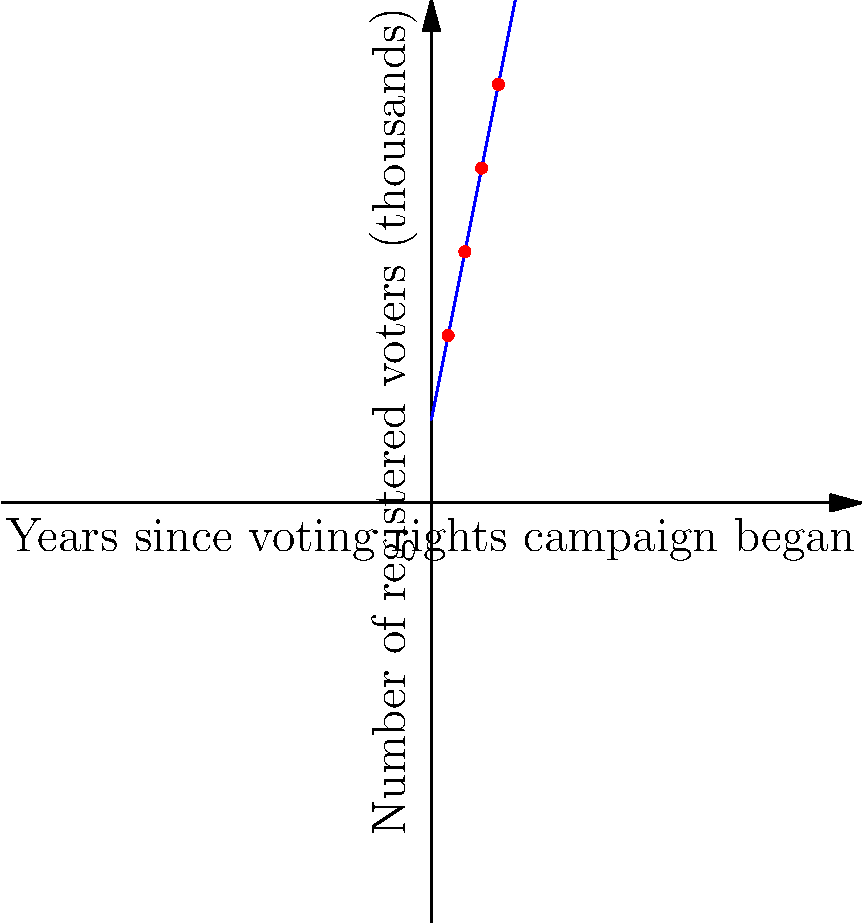The graph shows the trend of voter registration in a Southern state during a civil rights campaign. The x-axis represents years since the campaign began, and the y-axis represents the number of registered voters in thousands. The blue line represents the linear trend, and the red dots show actual data points. What is the rate of increase in voter registration per year, and what does this represent in the context of the civil rights movement? To determine the rate of increase in voter registration per year, we need to analyze the slope of the linear trend line. Let's approach this step-by-step:

1. The linear equation for a line is generally represented as $y = mx + b$, where $m$ is the slope and $b$ is the y-intercept.

2. We can determine the slope by picking two points on the line. Let's use (0,10) and (10,60):

   $m = \frac{y_2 - y_1}{x_2 - x_1} = \frac{60 - 10}{10 - 0} = \frac{50}{10} = 5$

3. This means that for each unit increase in x (each year), y increases by 5 units (5,000 voters).

4. We can verify this by checking the actual data points:
   - At year 2, we have 20,000 voters (5 * 2 + 10 = 20)
   - At year 4, we have 30,000 voters (5 * 4 + 10 = 30)
   - At year 6, we have 40,000 voters (5 * 6 + 10 = 40)
   - At year 8, we have 50,000 voters (5 * 8 + 10 = 50)

5. In the context of the civil rights movement, this represents a steady increase of 5,000 newly registered voters each year as a result of the voting rights campaign.

This consistent growth indicates the effectiveness of the civil rights campaign in encouraging voter registration and overcoming barriers to voting, which was a crucial aspect of the movement during the Jim Crow era.
Answer: 5,000 new voters registered per year, representing steady progress in voting rights. 